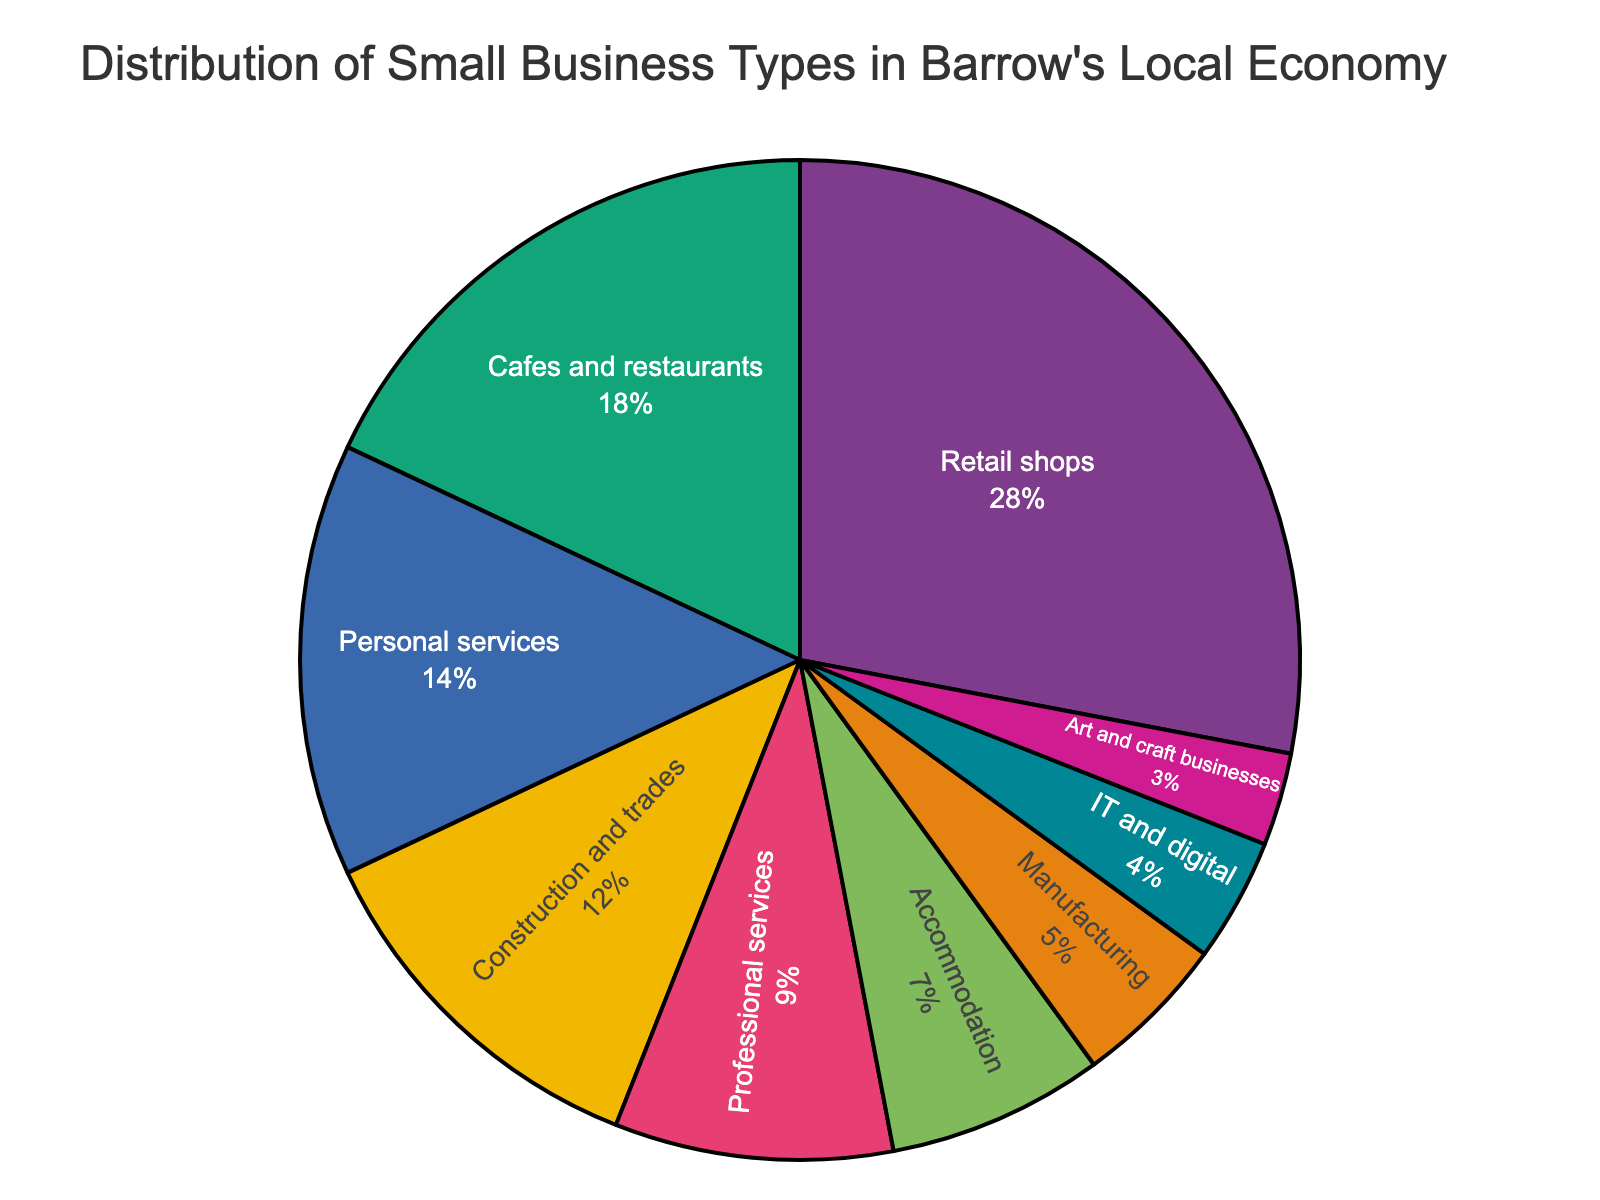Which type of business has the highest percentage? Visual inspection shows that the "Retail shops" slice occupies the largest portion of the pie chart.
Answer: Retail shops How much larger is the percentage of retail shops compared to professional services? Retail shops cover 28%, and professional services cover 9%. The difference is 28% - 9% = 19%.
Answer: 19% What is the combined percentage of cafes and restaurants, and personal services? Cafes and restaurants have 18%, and personal services have 14%. Their combined percentage is 18% + 14% = 32%.
Answer: 32% Which business type has the smallest percentage? Visual inspection shows that the "Art and craft businesses" slice is the smallest.
Answer: Art and craft businesses Is the percentage of cafes and restaurants more than three times that of IT and digital businesses? The percentage of cafes and restaurants is 18%. The percentage of IT and digital businesses is 4%. Three times 4% is 12%, and 18% is greater than 12%.
Answer: Yes What is the percentage difference between accommodation and manufacturing? Accommodation has 7%, and manufacturing has 5%. The difference is 7% - 5% = 2%.
Answer: 2% How do the combined percentages of manufacturing and IT and digital compare to the percentage of construction and trades? The combined percentage of manufacturing (5%) and IT and digital (4%) is 5% + 4% = 9%. Construction and trades is 12%. 9% is less than 12%.
Answer: Less What's the sum of the percentages of accommodation, manufacturing, and IT and digital businesses? Accommodation is 7%, manufacturing is 5%, and IT and digital is 4%. Their sum is 7% + 5% + 4% = 16%.
Answer: 16% Which business types have a combined total of 26%? Personal services (14%) and construction and trades (12%) combined equal 14% + 12% = 26%.
Answer: Personal services and construction and trades 